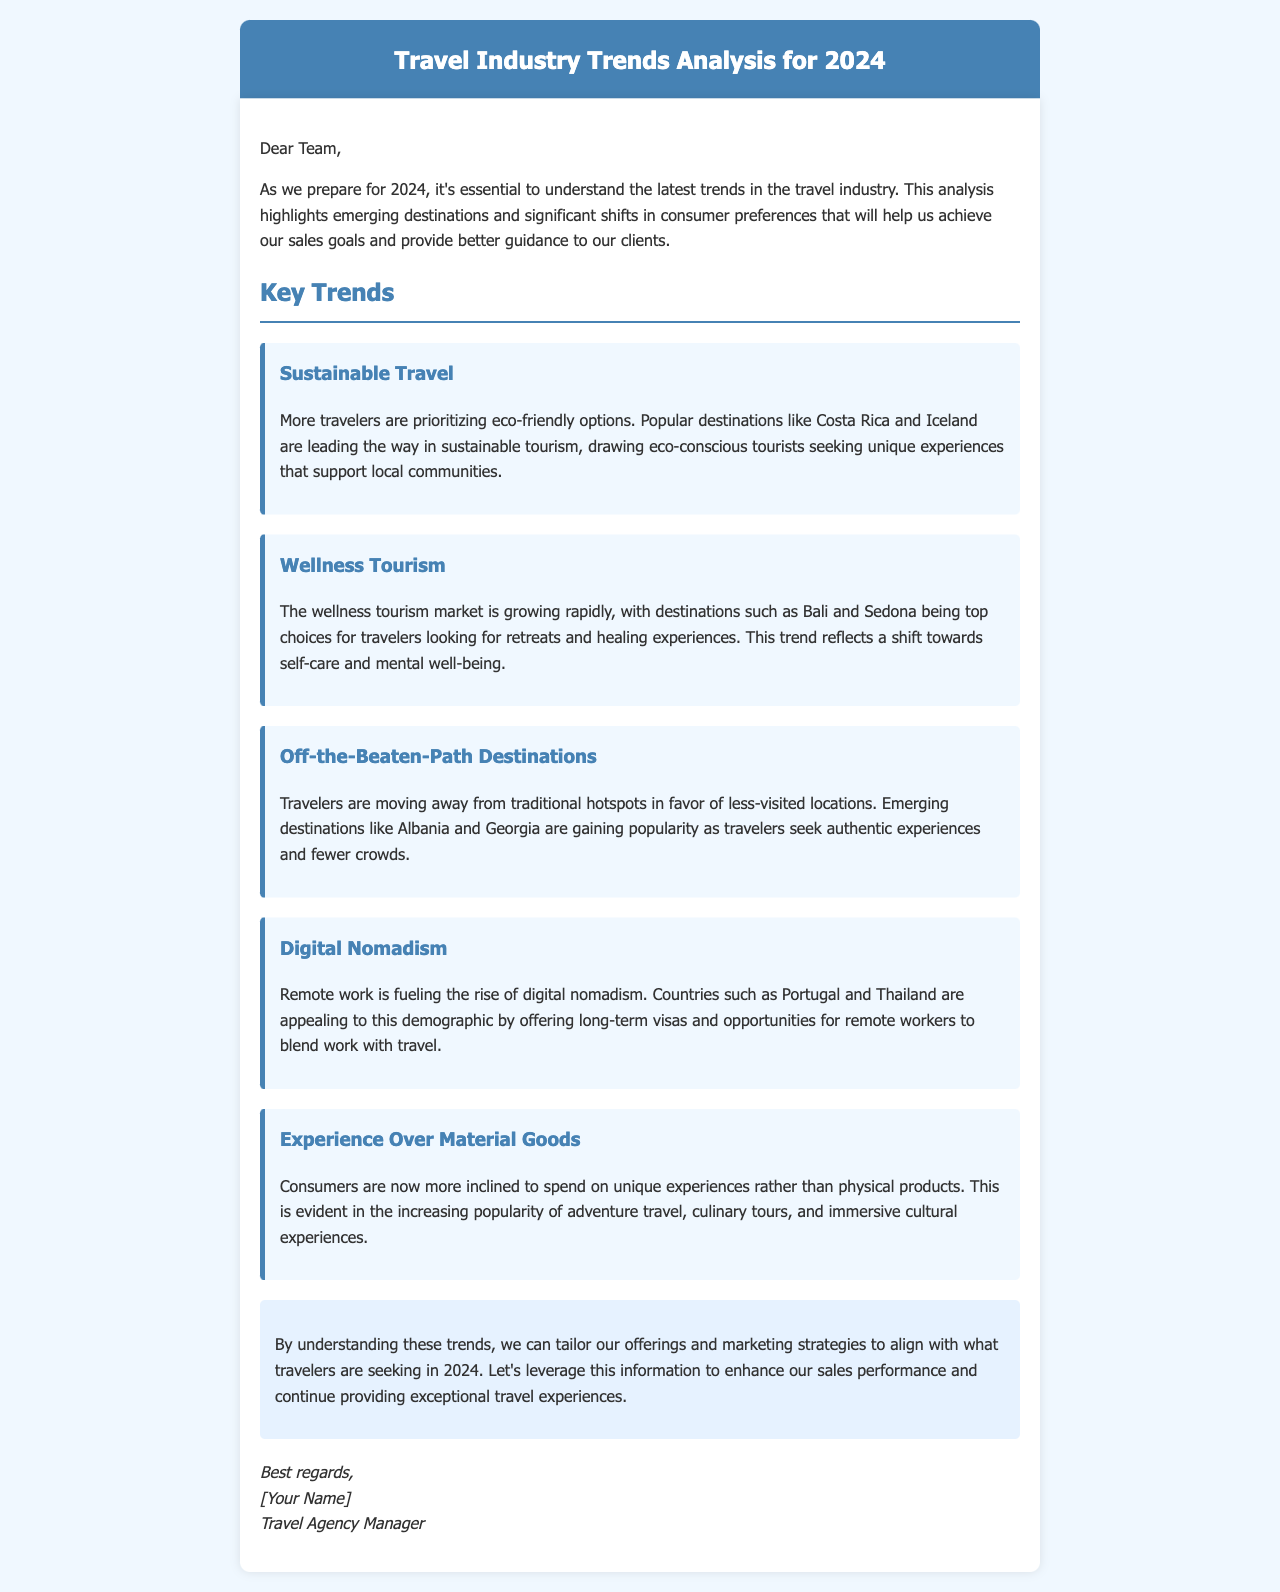What is the title of the document? The title appears at the top of the document in the header section.
Answer: Travel Industry Trends Analysis for 2024 Which destination is highlighted for sustainable travel? This information can be found in the section discussing sustainable travel trends.
Answer: Costa Rica What type of tourism is growing rapidly? This is mentioned in the section about wellness tourism.
Answer: Wellness Tourism Name one emerging destination mentioned for off-the-beaten-path travel. This is found in the section discussing less-visited locations.
Answer: Albania What are travelers increasingly inclined to spend on? This information is included in the section discussing consumer preferences.
Answer: Unique experiences Which countries are appealing to digital nomads? This is stated in the section on the rise of digital nomadism.
Answer: Portugal and Thailand What is one of the key trends affecting consumer preferences? This is summarized in the introduction and trends sections of the document.
Answer: Experience Over Material Goods What is the goal of this trends analysis? The purpose is highlighted in the introduction of the document.
Answer: Achieve sales goals and provide guidance How does the document conclude? The conclusion summarizes key insights to inform future strategies.
Answer: Tailor offerings and marketing strategies 